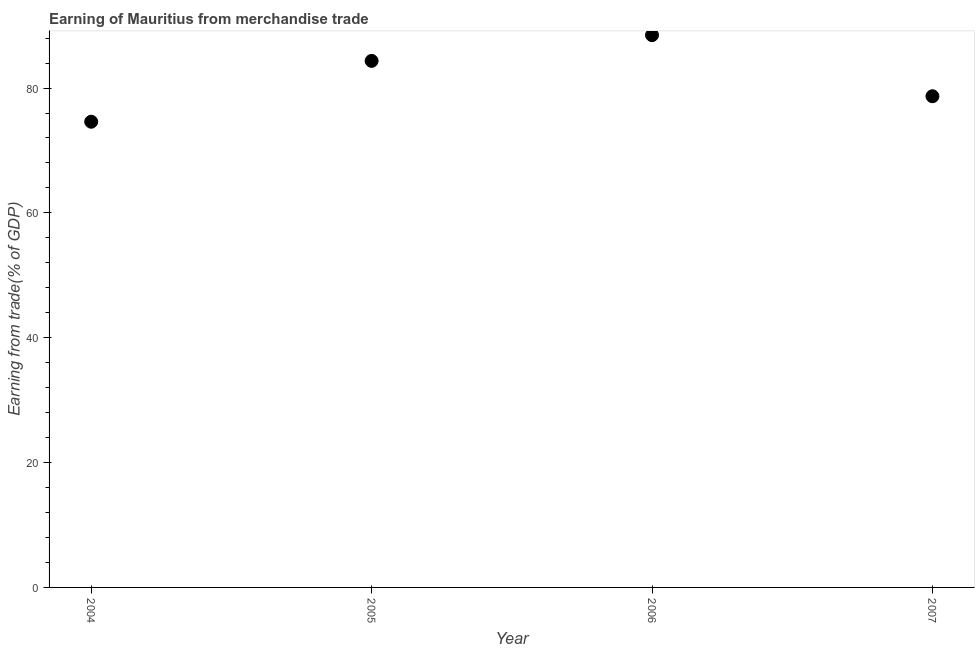What is the earning from merchandise trade in 2005?
Give a very brief answer. 84.35. Across all years, what is the maximum earning from merchandise trade?
Offer a very short reply. 88.47. Across all years, what is the minimum earning from merchandise trade?
Offer a terse response. 74.61. In which year was the earning from merchandise trade maximum?
Your response must be concise. 2006. What is the sum of the earning from merchandise trade?
Offer a very short reply. 326.12. What is the difference between the earning from merchandise trade in 2005 and 2006?
Offer a very short reply. -4.12. What is the average earning from merchandise trade per year?
Provide a short and direct response. 81.53. What is the median earning from merchandise trade?
Provide a succinct answer. 81.52. Do a majority of the years between 2007 and 2006 (inclusive) have earning from merchandise trade greater than 68 %?
Your response must be concise. No. What is the ratio of the earning from merchandise trade in 2005 to that in 2006?
Your response must be concise. 0.95. Is the earning from merchandise trade in 2006 less than that in 2007?
Your answer should be compact. No. What is the difference between the highest and the second highest earning from merchandise trade?
Offer a terse response. 4.12. What is the difference between the highest and the lowest earning from merchandise trade?
Ensure brevity in your answer.  13.87. In how many years, is the earning from merchandise trade greater than the average earning from merchandise trade taken over all years?
Make the answer very short. 2. Does the earning from merchandise trade monotonically increase over the years?
Give a very brief answer. No. Are the values on the major ticks of Y-axis written in scientific E-notation?
Your response must be concise. No. Does the graph contain grids?
Offer a very short reply. No. What is the title of the graph?
Your answer should be compact. Earning of Mauritius from merchandise trade. What is the label or title of the X-axis?
Make the answer very short. Year. What is the label or title of the Y-axis?
Make the answer very short. Earning from trade(% of GDP). What is the Earning from trade(% of GDP) in 2004?
Keep it short and to the point. 74.61. What is the Earning from trade(% of GDP) in 2005?
Your response must be concise. 84.35. What is the Earning from trade(% of GDP) in 2006?
Your answer should be compact. 88.47. What is the Earning from trade(% of GDP) in 2007?
Keep it short and to the point. 78.69. What is the difference between the Earning from trade(% of GDP) in 2004 and 2005?
Your response must be concise. -9.74. What is the difference between the Earning from trade(% of GDP) in 2004 and 2006?
Offer a very short reply. -13.87. What is the difference between the Earning from trade(% of GDP) in 2004 and 2007?
Offer a terse response. -4.08. What is the difference between the Earning from trade(% of GDP) in 2005 and 2006?
Give a very brief answer. -4.12. What is the difference between the Earning from trade(% of GDP) in 2005 and 2007?
Your response must be concise. 5.66. What is the difference between the Earning from trade(% of GDP) in 2006 and 2007?
Provide a succinct answer. 9.78. What is the ratio of the Earning from trade(% of GDP) in 2004 to that in 2005?
Your response must be concise. 0.88. What is the ratio of the Earning from trade(% of GDP) in 2004 to that in 2006?
Keep it short and to the point. 0.84. What is the ratio of the Earning from trade(% of GDP) in 2004 to that in 2007?
Offer a very short reply. 0.95. What is the ratio of the Earning from trade(% of GDP) in 2005 to that in 2006?
Make the answer very short. 0.95. What is the ratio of the Earning from trade(% of GDP) in 2005 to that in 2007?
Offer a terse response. 1.07. What is the ratio of the Earning from trade(% of GDP) in 2006 to that in 2007?
Your answer should be compact. 1.12. 